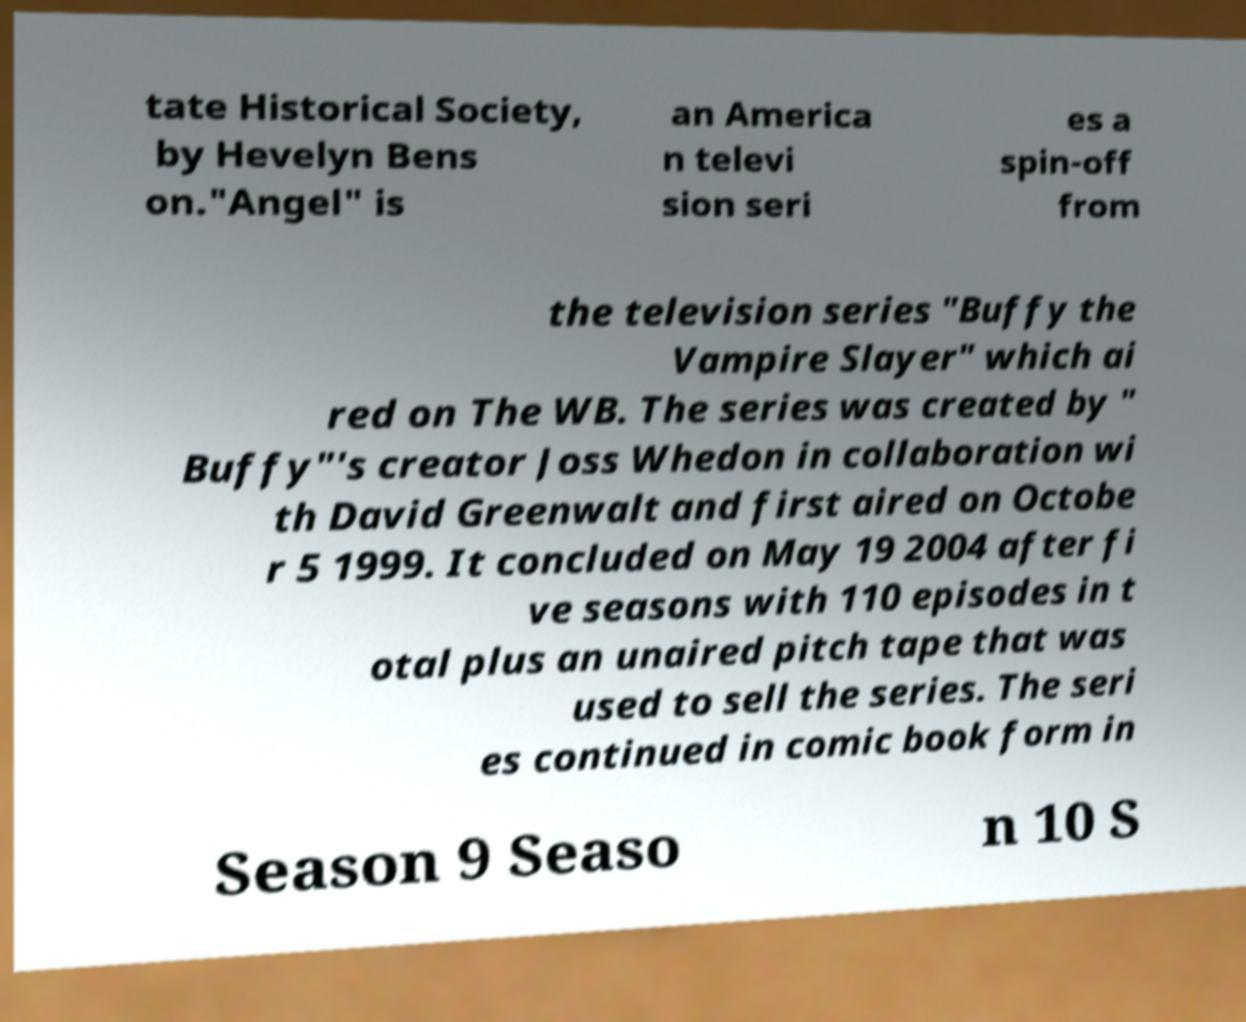For documentation purposes, I need the text within this image transcribed. Could you provide that? tate Historical Society, by Hevelyn Bens on."Angel" is an America n televi sion seri es a spin-off from the television series "Buffy the Vampire Slayer" which ai red on The WB. The series was created by " Buffy"'s creator Joss Whedon in collaboration wi th David Greenwalt and first aired on Octobe r 5 1999. It concluded on May 19 2004 after fi ve seasons with 110 episodes in t otal plus an unaired pitch tape that was used to sell the series. The seri es continued in comic book form in Season 9 Seaso n 10 S 